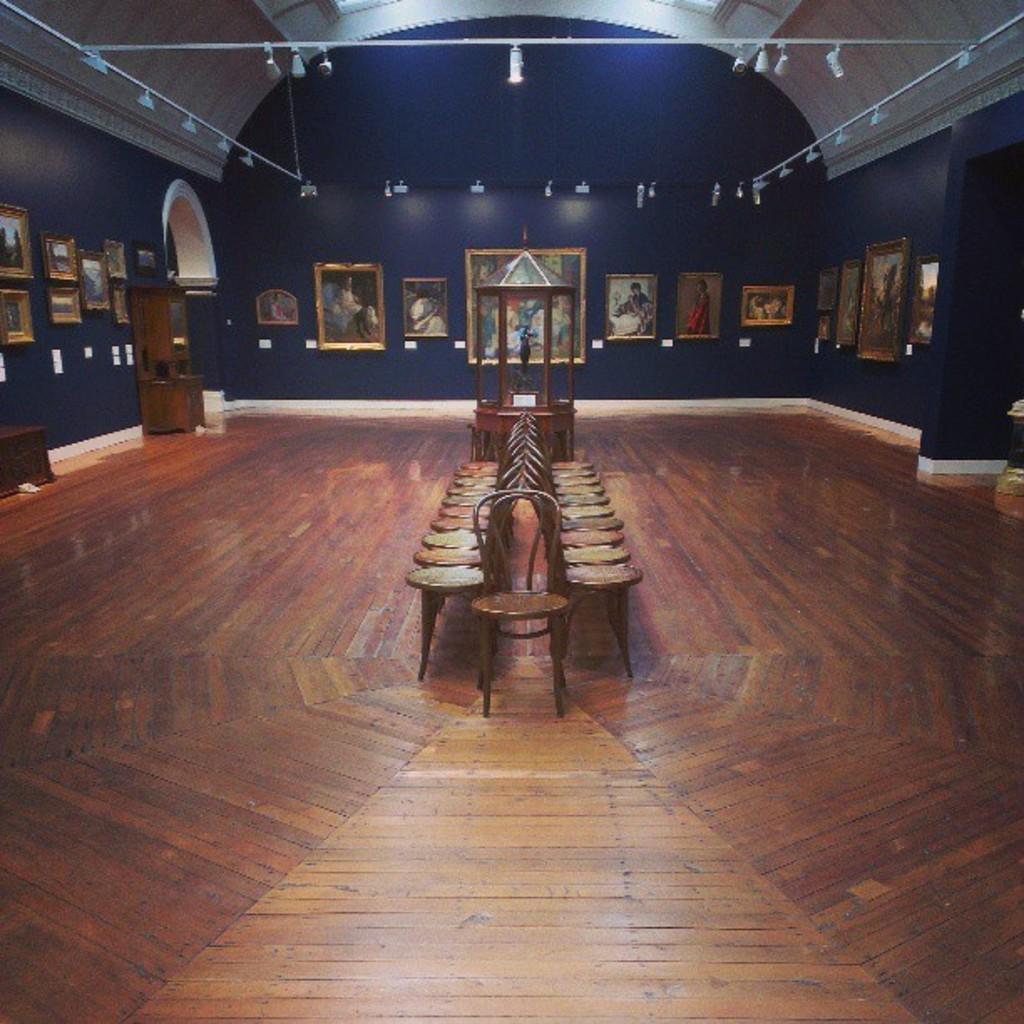Please provide a concise description of this image. This image is taken indoors. At the bottom of the image there is a floor. In the middle of the image there are many empty chairs and something in the box. In the background there is a wall with many picture frames and paintings on it. At the top of the image there is a roof and there are a few lights. 